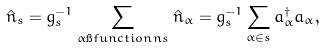Convert formula to latex. <formula><loc_0><loc_0><loc_500><loc_500>\hat { n } _ { s } = g _ { s } ^ { - 1 } \sum _ { \alpha \i f u n c t i o n n s } \hat { n } _ { \alpha } = g _ { s } ^ { - 1 } \sum _ { \alpha \in s } a ^ { \dagger } _ { \alpha } a _ { \alpha } ,</formula> 